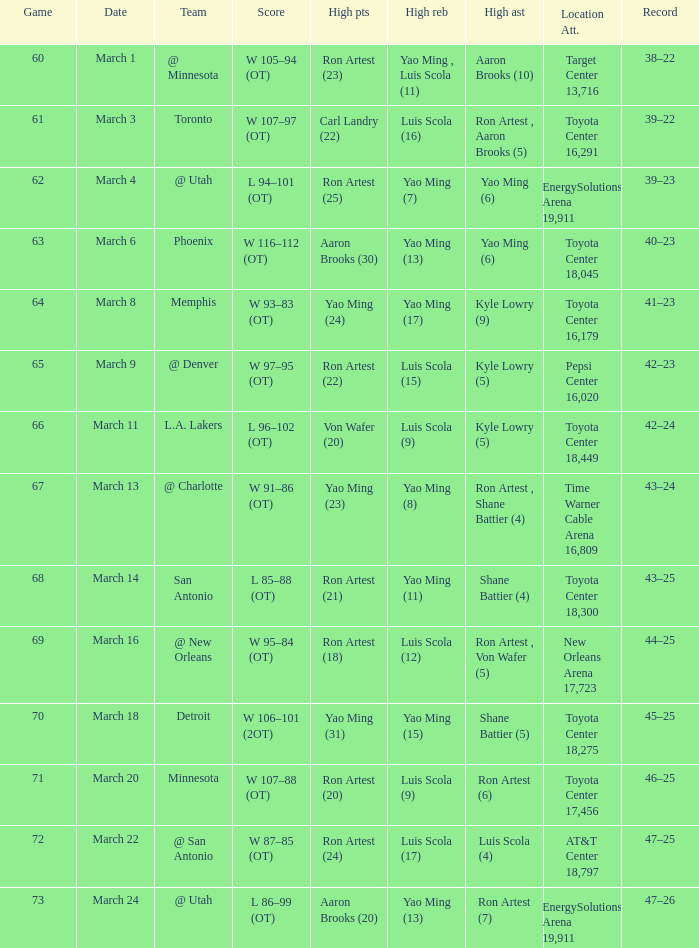Could you parse the entire table? {'header': ['Game', 'Date', 'Team', 'Score', 'High pts', 'High reb', 'High ast', 'Location Att.', 'Record'], 'rows': [['60', 'March 1', '@ Minnesota', 'W 105–94 (OT)', 'Ron Artest (23)', 'Yao Ming , Luis Scola (11)', 'Aaron Brooks (10)', 'Target Center 13,716', '38–22'], ['61', 'March 3', 'Toronto', 'W 107–97 (OT)', 'Carl Landry (22)', 'Luis Scola (16)', 'Ron Artest , Aaron Brooks (5)', 'Toyota Center 16,291', '39–22'], ['62', 'March 4', '@ Utah', 'L 94–101 (OT)', 'Ron Artest (25)', 'Yao Ming (7)', 'Yao Ming (6)', 'EnergySolutions Arena 19,911', '39–23'], ['63', 'March 6', 'Phoenix', 'W 116–112 (OT)', 'Aaron Brooks (30)', 'Yao Ming (13)', 'Yao Ming (6)', 'Toyota Center 18,045', '40–23'], ['64', 'March 8', 'Memphis', 'W 93–83 (OT)', 'Yao Ming (24)', 'Yao Ming (17)', 'Kyle Lowry (9)', 'Toyota Center 16,179', '41–23'], ['65', 'March 9', '@ Denver', 'W 97–95 (OT)', 'Ron Artest (22)', 'Luis Scola (15)', 'Kyle Lowry (5)', 'Pepsi Center 16,020', '42–23'], ['66', 'March 11', 'L.A. Lakers', 'L 96–102 (OT)', 'Von Wafer (20)', 'Luis Scola (9)', 'Kyle Lowry (5)', 'Toyota Center 18,449', '42–24'], ['67', 'March 13', '@ Charlotte', 'W 91–86 (OT)', 'Yao Ming (23)', 'Yao Ming (8)', 'Ron Artest , Shane Battier (4)', 'Time Warner Cable Arena 16,809', '43–24'], ['68', 'March 14', 'San Antonio', 'L 85–88 (OT)', 'Ron Artest (21)', 'Yao Ming (11)', 'Shane Battier (4)', 'Toyota Center 18,300', '43–25'], ['69', 'March 16', '@ New Orleans', 'W 95–84 (OT)', 'Ron Artest (18)', 'Luis Scola (12)', 'Ron Artest , Von Wafer (5)', 'New Orleans Arena 17,723', '44–25'], ['70', 'March 18', 'Detroit', 'W 106–101 (2OT)', 'Yao Ming (31)', 'Yao Ming (15)', 'Shane Battier (5)', 'Toyota Center 18,275', '45–25'], ['71', 'March 20', 'Minnesota', 'W 107–88 (OT)', 'Ron Artest (20)', 'Luis Scola (9)', 'Ron Artest (6)', 'Toyota Center 17,456', '46–25'], ['72', 'March 22', '@ San Antonio', 'W 87–85 (OT)', 'Ron Artest (24)', 'Luis Scola (17)', 'Luis Scola (4)', 'AT&T Center 18,797', '47–25'], ['73', 'March 24', '@ Utah', 'L 86–99 (OT)', 'Aaron Brooks (20)', 'Yao Ming (13)', 'Ron Artest (7)', 'EnergySolutions Arena 19,911', '47–26']]} Who scored the highest points in game 72? Ron Artest (24). 